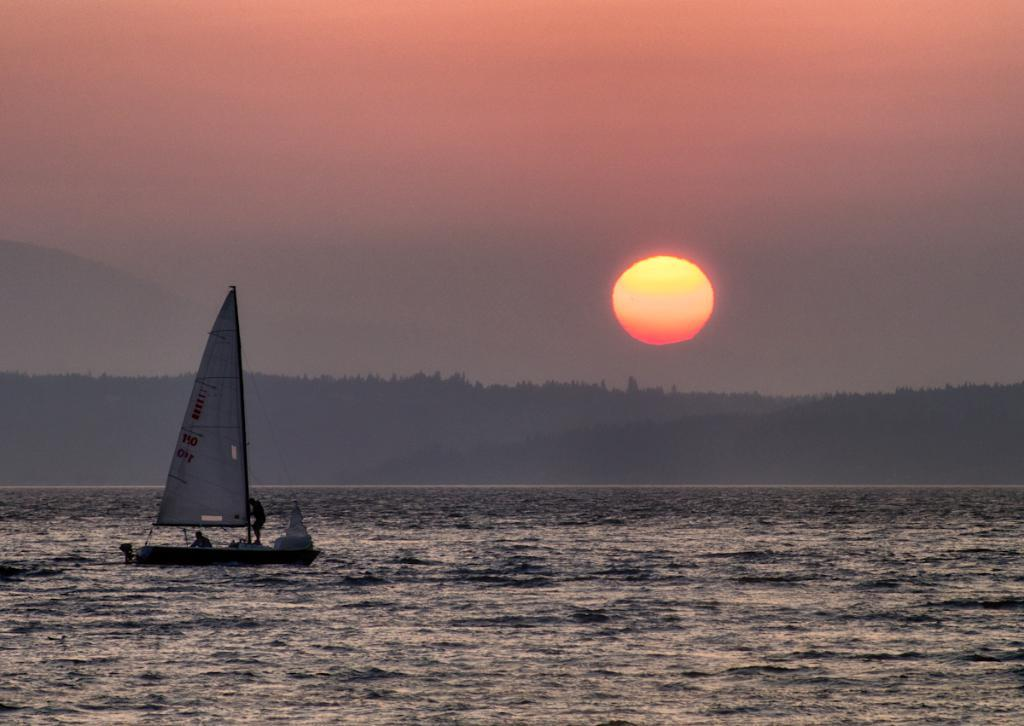What is located on the left side of the image? There is a boat on the water on the left side of the image. Who or what is inside the boat? There are people in the boat. What can be seen in the background of the image? There are trees and the sun visible in the background of the image. What type of cork can be seen floating near the boat in the image? There is no cork visible in the image; it only features a boat with people on the water and trees and the sun in the background. 